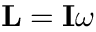<formula> <loc_0><loc_0><loc_500><loc_500>L = I \omega</formula> 